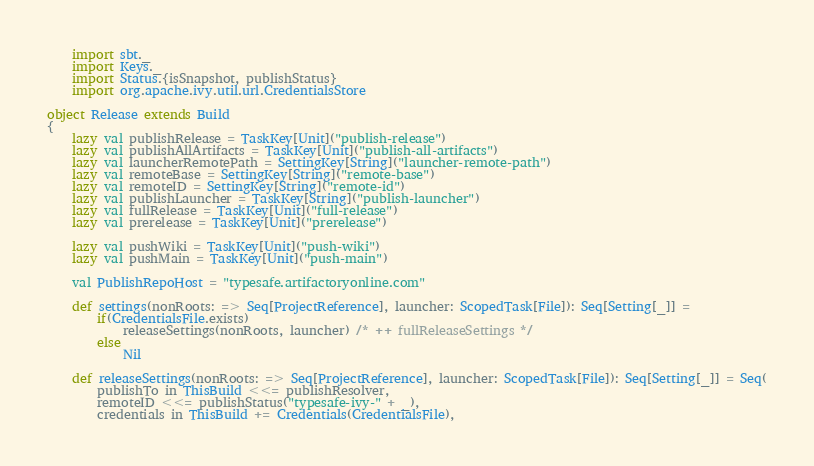Convert code to text. <code><loc_0><loc_0><loc_500><loc_500><_Scala_>	import sbt._
	import Keys._
	import Status.{isSnapshot, publishStatus}
	import org.apache.ivy.util.url.CredentialsStore

object Release extends Build
{
	lazy val publishRelease = TaskKey[Unit]("publish-release")
	lazy val publishAllArtifacts = TaskKey[Unit]("publish-all-artifacts")
	lazy val launcherRemotePath = SettingKey[String]("launcher-remote-path")
	lazy val remoteBase = SettingKey[String]("remote-base")
	lazy val remoteID = SettingKey[String]("remote-id")
	lazy val publishLauncher = TaskKey[String]("publish-launcher")
	lazy val fullRelease = TaskKey[Unit]("full-release")
	lazy val prerelease = TaskKey[Unit]("prerelease")

	lazy val pushWiki = TaskKey[Unit]("push-wiki")
	lazy val pushMain = TaskKey[Unit]("push-main")

	val PublishRepoHost = "typesafe.artifactoryonline.com"

	def settings(nonRoots: => Seq[ProjectReference], launcher: ScopedTask[File]): Seq[Setting[_]] =
		if(CredentialsFile.exists)
			releaseSettings(nonRoots, launcher) /* ++ fullReleaseSettings */
		else
			Nil

	def releaseSettings(nonRoots: => Seq[ProjectReference], launcher: ScopedTask[File]): Seq[Setting[_]] = Seq(
		publishTo in ThisBuild <<= publishResolver,
		remoteID <<= publishStatus("typesafe-ivy-" + _),
		credentials in ThisBuild += Credentials(CredentialsFile),</code> 